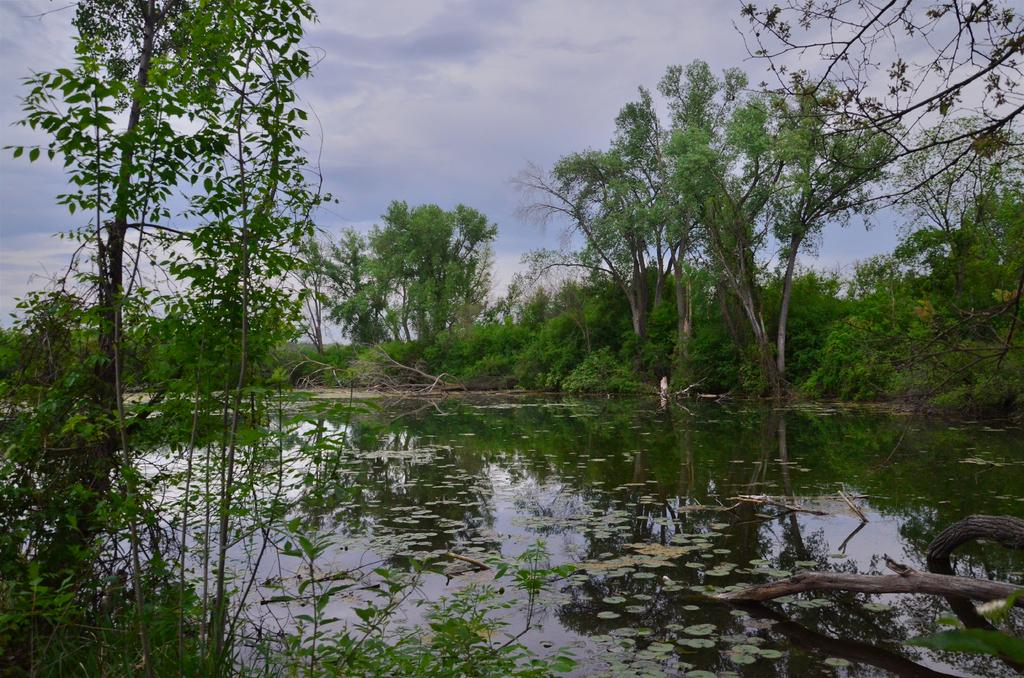What can be seen in the sky in the image? The sky with clouds is visible in the image. What type of vegetation is present in the image? There are trees and plants in the image. What is the leaves in the image suggest about the season? The presence of leaves suggests that it is not winter. What body of water is visible in the image? There is a lake in the image. What type of books can be seen in the library in the image? There is no library present in the image, as it features natural elements such as the sky, trees, plants, leaves, and a lake. 